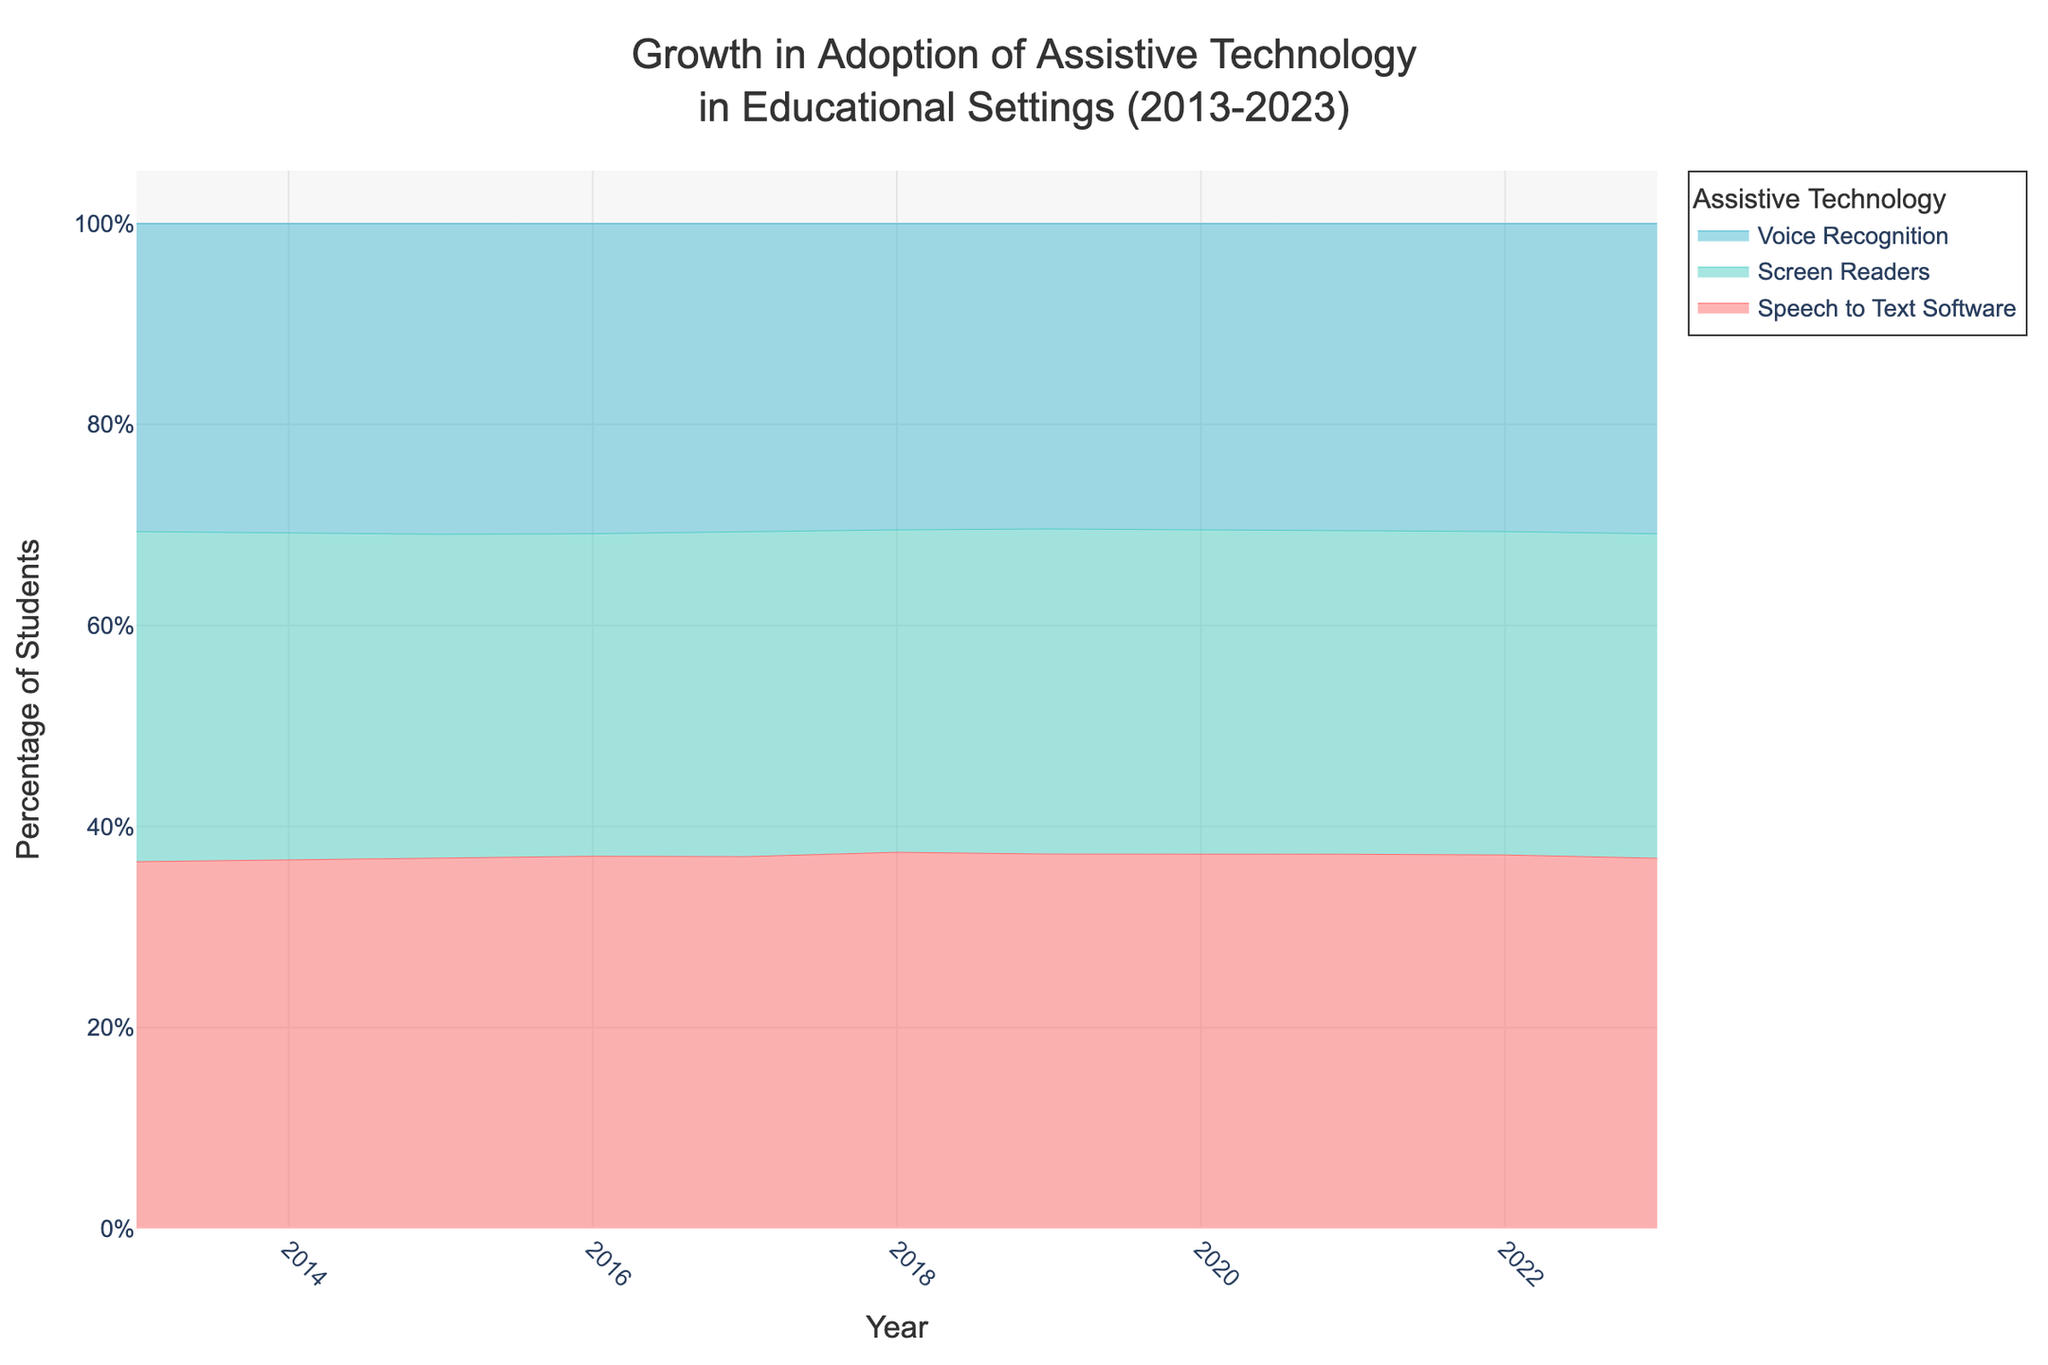what is the title of the chart? The title of the chart is located at the top and is intended to provide an overview of what the chart represents. The title reads "Growth in Adoption of Assistive Technology in Educational Settings (2013-2023)".
Answer: Growth in Adoption of Assistive Technology in Educational Settings (2013-2023) what does the x-axis represent? The x-axis, which runs horizontally at the bottom of the chart, represents the time component and is labeled “Year”. It shows a range from 2013 to 2023.
Answer: Year what does the y-axis represent? The y-axis, which runs vertically along the side of the chart, is labeled "Percentage of Students". It quantifies the percentage of students using assistive technology.
Answer: Percentage of Students how many assistive technologies are displayed in the chart? The chart uses different colored lines to display data for three different assistive technologies. The legend on the right side of the chart identifies these technologies, which are Speech to Text Software, Screen Readers, and Voice Recognition.
Answer: Three which assistive technology had the highest adoption rate in 2023? By looking at the endpoint of the lines corresponding to each technology in 2023, the highest line indicates the one with the highest adoption rate.
Answer: Speech to Text Software what trend can you observe for the Screen Readers technology from 2013 to 2023? The trend for Screen Readers can be observed by following the line representing this technology from 2013 to 2023. It shows a consistent upward trend, indicating an increase in the number of students using Screen Readers over the years.
Answer: Consistent increase by how much did the number of students using Voice Recognition increase from 2013 to 2023? To determine the increase, find the number of students using Voice Recognition in 2013 and 2023, then calculate the difference. In 2013, there were 4200 students, and in 2023, there were 8800 students. The increase is 8800 - 4200.
Answer: 4600 which technology showed the most significant increase in adoption between 2019 and 2020? To identify the technology with the most significant increase, observe the slope of each line between 2019 and 2020. The steepest slope indicates the largest annual increase.
Answer: Speech to Text Software which assistive technology had the least adoption in 2018? Examine the points in 2018 for each technology. The technology with the lowest position on the chart had the least adoption.
Answer: Voice Recognition 